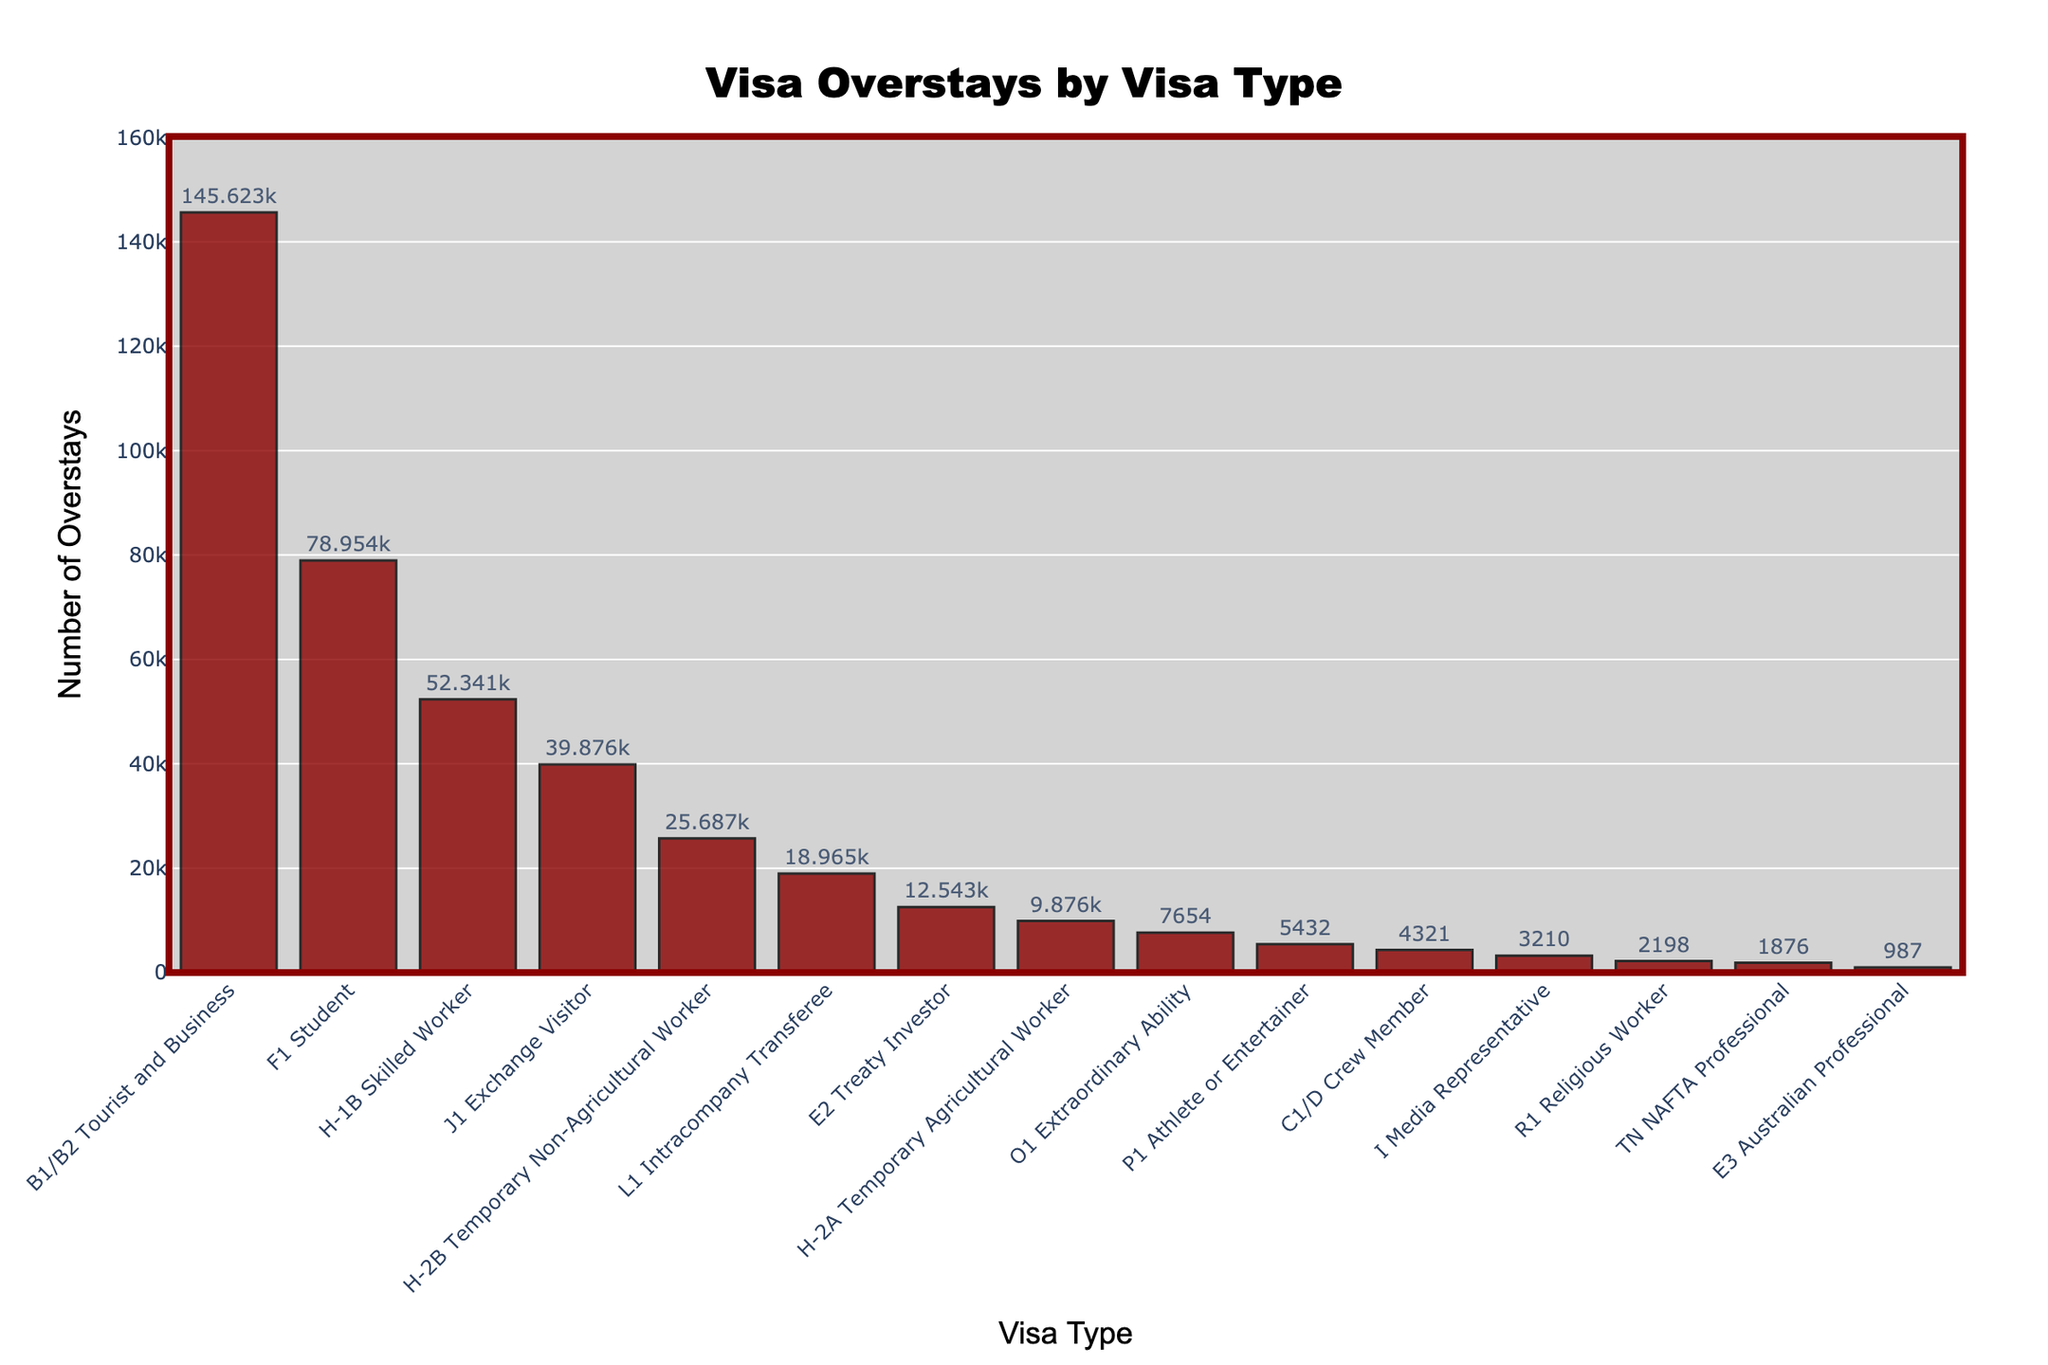Which visa type has the highest number of overstays? The visa type with the highest number of overstays is determined by looking at the tallest bar in the bar chart.
Answer: B1/B2 Tourist and Business Which visa types have fewer than 10,000 overstays? Count the bars which have a height representing fewer than 10,000 overstays.
Answer: H-2A Temporary Agricultural Worker, O1 Extraordinary Ability, P1 Athlete or Entertainer, C1/D Crew Member, I Media Representative, R1 Religious Worker, TN NAFTA Professional, E3 Australian Professional What's the total number of overstays for H-1B Skilled Worker and F1 Student visas? Add the number of overstays for H-1B Skilled Worker (52,341) and F1 Student (78,954): 52,341 + 78,954 = 131,295.
Answer: 131,295 Which visa types have a similar number of overstays, around 40,000? Find visa types whose bars are close in height to the value of approximately 40,000 overstays.
Answer: H-1B Skilled Worker and J1 Exchange Visitor How do the overstays for the J1 Exchange Visitor compare to the E2 Treaty Investor? Compare the heights of the bars for J1 Exchange Visitor and E2 Treaty Investor. The J1 Exchange Visitor has a significantly higher number of overstays.
Answer: J1 Exchange Visitor has more overstays What's the difference in the number of overstays between the visa type with the highest and the lowest overstays? Subtract the number of overstays of the visa type with the lowest overstays (E3 Australian Professional, 987) from the visa type with the highest overstays (B1/B2 Tourist and Business, 145,623): 145,623 - 987 = 144,636.
Answer: 144,636 Between H-2B Temporary Non-Agricultural Worker and H-2A Temporary Agricultural Worker, which has more overstays and by how much? H-2B has 25,687 overstays, and H-2A has 9,876 overstays. The difference is 25,687 - 9,876 = 15,811.
Answer: H-2B by 15,811 What's the median number of overstays among all visa types? First, list out all the number values: [987, 1876, 2198, 3210, 4321, 5432, 7654, 9876, 12543, 18965, 25687, 39876, 52341, 78954, 145623]. The median is the middle value in this sorted list. Here the median value is (12543 + 18965) / 2 = 15,754.
Answer: 15,754 What percentage of the total overstays is contributed by F1 Student and J1 Exchange Visitor combined? First, calculate the total number of overstays: 145623 + 78954 + 52341 + 39876 + 25687 + 18965 + 12543 + 9876 + 7654 + 5432 + 4321 + 3210 + 2198 + 1876 + 987 = 352,547. Then sum the overstays for F1 Student and J1 Exchange Visitor: 78,954 + 39,876 = 118,830. Finally, calculate the percentage: (118,830 / 352,547) * 100 = 33.7%.
Answer: 33.7% 